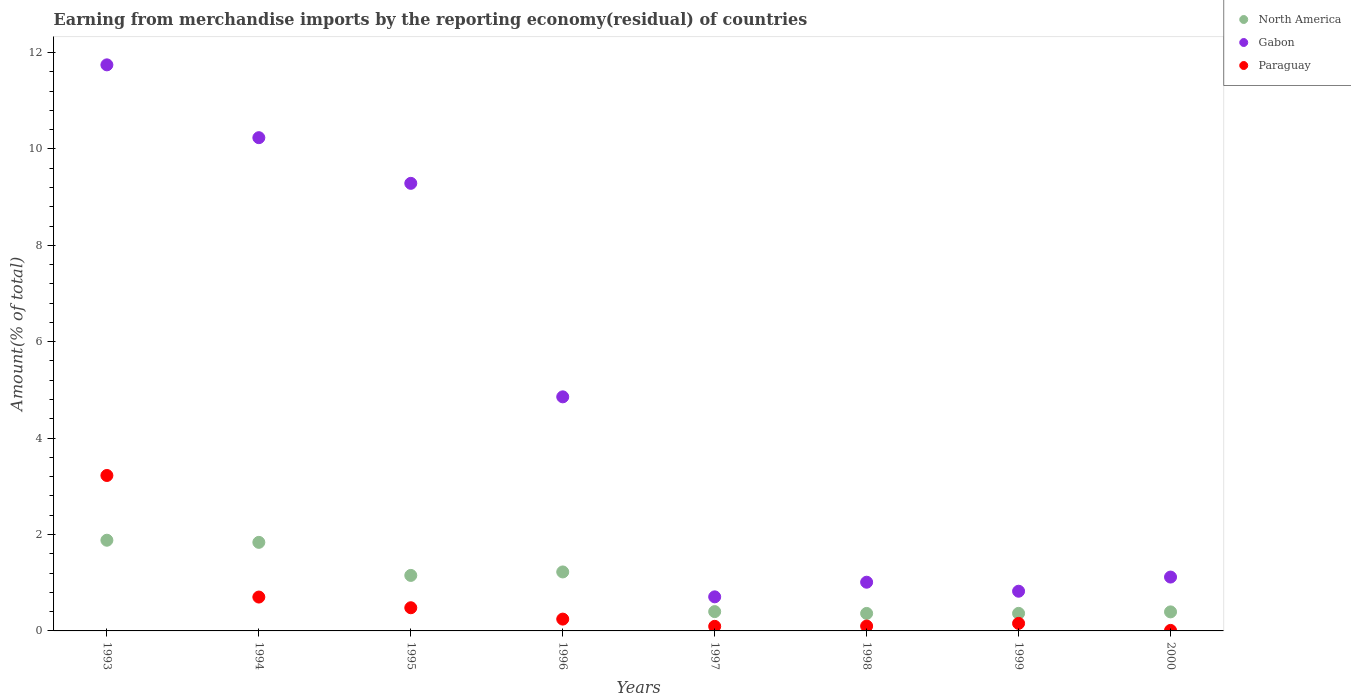Is the number of dotlines equal to the number of legend labels?
Offer a terse response. Yes. What is the percentage of amount earned from merchandise imports in Paraguay in 1994?
Your answer should be very brief. 0.7. Across all years, what is the maximum percentage of amount earned from merchandise imports in Gabon?
Your answer should be compact. 11.74. Across all years, what is the minimum percentage of amount earned from merchandise imports in Gabon?
Provide a short and direct response. 0.71. What is the total percentage of amount earned from merchandise imports in Gabon in the graph?
Give a very brief answer. 39.77. What is the difference between the percentage of amount earned from merchandise imports in North America in 1995 and that in 2000?
Keep it short and to the point. 0.76. What is the difference between the percentage of amount earned from merchandise imports in Gabon in 1993 and the percentage of amount earned from merchandise imports in North America in 1999?
Ensure brevity in your answer.  11.38. What is the average percentage of amount earned from merchandise imports in North America per year?
Give a very brief answer. 0.95. In the year 1995, what is the difference between the percentage of amount earned from merchandise imports in Paraguay and percentage of amount earned from merchandise imports in North America?
Your answer should be very brief. -0.67. In how many years, is the percentage of amount earned from merchandise imports in North America greater than 7.6 %?
Make the answer very short. 0. What is the ratio of the percentage of amount earned from merchandise imports in Paraguay in 1995 to that in 1998?
Your answer should be compact. 4.77. Is the percentage of amount earned from merchandise imports in Paraguay in 1995 less than that in 1997?
Your response must be concise. No. What is the difference between the highest and the second highest percentage of amount earned from merchandise imports in Paraguay?
Offer a terse response. 2.52. What is the difference between the highest and the lowest percentage of amount earned from merchandise imports in North America?
Your response must be concise. 1.52. Is the sum of the percentage of amount earned from merchandise imports in Paraguay in 1995 and 1996 greater than the maximum percentage of amount earned from merchandise imports in Gabon across all years?
Give a very brief answer. No. Is it the case that in every year, the sum of the percentage of amount earned from merchandise imports in North America and percentage of amount earned from merchandise imports in Paraguay  is greater than the percentage of amount earned from merchandise imports in Gabon?
Your response must be concise. No. Is the percentage of amount earned from merchandise imports in Paraguay strictly less than the percentage of amount earned from merchandise imports in Gabon over the years?
Give a very brief answer. Yes. How many years are there in the graph?
Provide a short and direct response. 8. Does the graph contain any zero values?
Your answer should be compact. No. Does the graph contain grids?
Offer a terse response. No. How many legend labels are there?
Offer a very short reply. 3. How are the legend labels stacked?
Make the answer very short. Vertical. What is the title of the graph?
Your answer should be very brief. Earning from merchandise imports by the reporting economy(residual) of countries. What is the label or title of the X-axis?
Keep it short and to the point. Years. What is the label or title of the Y-axis?
Provide a short and direct response. Amount(% of total). What is the Amount(% of total) in North America in 1993?
Give a very brief answer. 1.88. What is the Amount(% of total) of Gabon in 1993?
Your response must be concise. 11.74. What is the Amount(% of total) in Paraguay in 1993?
Your answer should be compact. 3.22. What is the Amount(% of total) of North America in 1994?
Keep it short and to the point. 1.84. What is the Amount(% of total) of Gabon in 1994?
Keep it short and to the point. 10.23. What is the Amount(% of total) in Paraguay in 1994?
Offer a very short reply. 0.7. What is the Amount(% of total) in North America in 1995?
Provide a succinct answer. 1.15. What is the Amount(% of total) in Gabon in 1995?
Your answer should be very brief. 9.29. What is the Amount(% of total) in Paraguay in 1995?
Offer a very short reply. 0.48. What is the Amount(% of total) of North America in 1996?
Make the answer very short. 1.22. What is the Amount(% of total) in Gabon in 1996?
Offer a very short reply. 4.86. What is the Amount(% of total) in Paraguay in 1996?
Offer a terse response. 0.25. What is the Amount(% of total) of North America in 1997?
Provide a short and direct response. 0.4. What is the Amount(% of total) of Gabon in 1997?
Offer a terse response. 0.71. What is the Amount(% of total) in Paraguay in 1997?
Offer a terse response. 0.09. What is the Amount(% of total) of North America in 1998?
Make the answer very short. 0.36. What is the Amount(% of total) in Gabon in 1998?
Keep it short and to the point. 1.01. What is the Amount(% of total) in Paraguay in 1998?
Provide a succinct answer. 0.1. What is the Amount(% of total) of North America in 1999?
Your response must be concise. 0.36. What is the Amount(% of total) of Gabon in 1999?
Make the answer very short. 0.82. What is the Amount(% of total) of Paraguay in 1999?
Your answer should be compact. 0.16. What is the Amount(% of total) of North America in 2000?
Make the answer very short. 0.39. What is the Amount(% of total) of Gabon in 2000?
Keep it short and to the point. 1.12. What is the Amount(% of total) in Paraguay in 2000?
Your answer should be compact. 0.01. Across all years, what is the maximum Amount(% of total) of North America?
Offer a very short reply. 1.88. Across all years, what is the maximum Amount(% of total) of Gabon?
Give a very brief answer. 11.74. Across all years, what is the maximum Amount(% of total) in Paraguay?
Keep it short and to the point. 3.22. Across all years, what is the minimum Amount(% of total) in North America?
Provide a short and direct response. 0.36. Across all years, what is the minimum Amount(% of total) in Gabon?
Offer a terse response. 0.71. Across all years, what is the minimum Amount(% of total) in Paraguay?
Give a very brief answer. 0.01. What is the total Amount(% of total) in North America in the graph?
Make the answer very short. 7.62. What is the total Amount(% of total) of Gabon in the graph?
Give a very brief answer. 39.77. What is the total Amount(% of total) in Paraguay in the graph?
Offer a terse response. 5.02. What is the difference between the Amount(% of total) in North America in 1993 and that in 1994?
Provide a short and direct response. 0.04. What is the difference between the Amount(% of total) of Gabon in 1993 and that in 1994?
Keep it short and to the point. 1.51. What is the difference between the Amount(% of total) of Paraguay in 1993 and that in 1994?
Make the answer very short. 2.52. What is the difference between the Amount(% of total) of North America in 1993 and that in 1995?
Your answer should be very brief. 0.73. What is the difference between the Amount(% of total) of Gabon in 1993 and that in 1995?
Make the answer very short. 2.46. What is the difference between the Amount(% of total) in Paraguay in 1993 and that in 1995?
Give a very brief answer. 2.74. What is the difference between the Amount(% of total) in North America in 1993 and that in 1996?
Give a very brief answer. 0.66. What is the difference between the Amount(% of total) in Gabon in 1993 and that in 1996?
Keep it short and to the point. 6.89. What is the difference between the Amount(% of total) of Paraguay in 1993 and that in 1996?
Your response must be concise. 2.98. What is the difference between the Amount(% of total) of North America in 1993 and that in 1997?
Keep it short and to the point. 1.48. What is the difference between the Amount(% of total) in Gabon in 1993 and that in 1997?
Offer a very short reply. 11.04. What is the difference between the Amount(% of total) of Paraguay in 1993 and that in 1997?
Provide a short and direct response. 3.13. What is the difference between the Amount(% of total) of North America in 1993 and that in 1998?
Provide a succinct answer. 1.52. What is the difference between the Amount(% of total) of Gabon in 1993 and that in 1998?
Ensure brevity in your answer.  10.73. What is the difference between the Amount(% of total) in Paraguay in 1993 and that in 1998?
Give a very brief answer. 3.12. What is the difference between the Amount(% of total) of North America in 1993 and that in 1999?
Make the answer very short. 1.52. What is the difference between the Amount(% of total) in Gabon in 1993 and that in 1999?
Offer a terse response. 10.92. What is the difference between the Amount(% of total) in Paraguay in 1993 and that in 1999?
Provide a short and direct response. 3.07. What is the difference between the Amount(% of total) of North America in 1993 and that in 2000?
Give a very brief answer. 1.49. What is the difference between the Amount(% of total) in Gabon in 1993 and that in 2000?
Your answer should be compact. 10.63. What is the difference between the Amount(% of total) of Paraguay in 1993 and that in 2000?
Your response must be concise. 3.21. What is the difference between the Amount(% of total) of North America in 1994 and that in 1995?
Your answer should be very brief. 0.69. What is the difference between the Amount(% of total) in Gabon in 1994 and that in 1995?
Ensure brevity in your answer.  0.95. What is the difference between the Amount(% of total) in Paraguay in 1994 and that in 1995?
Make the answer very short. 0.22. What is the difference between the Amount(% of total) of North America in 1994 and that in 1996?
Offer a terse response. 0.61. What is the difference between the Amount(% of total) of Gabon in 1994 and that in 1996?
Make the answer very short. 5.38. What is the difference between the Amount(% of total) in Paraguay in 1994 and that in 1996?
Ensure brevity in your answer.  0.46. What is the difference between the Amount(% of total) in North America in 1994 and that in 1997?
Ensure brevity in your answer.  1.44. What is the difference between the Amount(% of total) of Gabon in 1994 and that in 1997?
Ensure brevity in your answer.  9.53. What is the difference between the Amount(% of total) of Paraguay in 1994 and that in 1997?
Provide a succinct answer. 0.61. What is the difference between the Amount(% of total) in North America in 1994 and that in 1998?
Ensure brevity in your answer.  1.47. What is the difference between the Amount(% of total) in Gabon in 1994 and that in 1998?
Provide a succinct answer. 9.22. What is the difference between the Amount(% of total) of Paraguay in 1994 and that in 1998?
Provide a short and direct response. 0.6. What is the difference between the Amount(% of total) in North America in 1994 and that in 1999?
Give a very brief answer. 1.47. What is the difference between the Amount(% of total) in Gabon in 1994 and that in 1999?
Keep it short and to the point. 9.41. What is the difference between the Amount(% of total) in Paraguay in 1994 and that in 1999?
Provide a short and direct response. 0.55. What is the difference between the Amount(% of total) in North America in 1994 and that in 2000?
Offer a terse response. 1.44. What is the difference between the Amount(% of total) in Gabon in 1994 and that in 2000?
Make the answer very short. 9.12. What is the difference between the Amount(% of total) in Paraguay in 1994 and that in 2000?
Provide a short and direct response. 0.69. What is the difference between the Amount(% of total) of North America in 1995 and that in 1996?
Your answer should be very brief. -0.07. What is the difference between the Amount(% of total) of Gabon in 1995 and that in 1996?
Give a very brief answer. 4.43. What is the difference between the Amount(% of total) of Paraguay in 1995 and that in 1996?
Give a very brief answer. 0.24. What is the difference between the Amount(% of total) of North America in 1995 and that in 1997?
Keep it short and to the point. 0.75. What is the difference between the Amount(% of total) of Gabon in 1995 and that in 1997?
Make the answer very short. 8.58. What is the difference between the Amount(% of total) of Paraguay in 1995 and that in 1997?
Your response must be concise. 0.39. What is the difference between the Amount(% of total) in North America in 1995 and that in 1998?
Keep it short and to the point. 0.79. What is the difference between the Amount(% of total) in Gabon in 1995 and that in 1998?
Your response must be concise. 8.27. What is the difference between the Amount(% of total) of Paraguay in 1995 and that in 1998?
Keep it short and to the point. 0.38. What is the difference between the Amount(% of total) in North America in 1995 and that in 1999?
Offer a very short reply. 0.79. What is the difference between the Amount(% of total) of Gabon in 1995 and that in 1999?
Give a very brief answer. 8.46. What is the difference between the Amount(% of total) of Paraguay in 1995 and that in 1999?
Your answer should be very brief. 0.32. What is the difference between the Amount(% of total) in North America in 1995 and that in 2000?
Your answer should be compact. 0.76. What is the difference between the Amount(% of total) in Gabon in 1995 and that in 2000?
Make the answer very short. 8.17. What is the difference between the Amount(% of total) of Paraguay in 1995 and that in 2000?
Offer a terse response. 0.47. What is the difference between the Amount(% of total) of North America in 1996 and that in 1997?
Ensure brevity in your answer.  0.82. What is the difference between the Amount(% of total) of Gabon in 1996 and that in 1997?
Offer a very short reply. 4.15. What is the difference between the Amount(% of total) of Paraguay in 1996 and that in 1997?
Ensure brevity in your answer.  0.15. What is the difference between the Amount(% of total) of North America in 1996 and that in 1998?
Make the answer very short. 0.86. What is the difference between the Amount(% of total) in Gabon in 1996 and that in 1998?
Keep it short and to the point. 3.85. What is the difference between the Amount(% of total) in Paraguay in 1996 and that in 1998?
Keep it short and to the point. 0.14. What is the difference between the Amount(% of total) in North America in 1996 and that in 1999?
Make the answer very short. 0.86. What is the difference between the Amount(% of total) of Gabon in 1996 and that in 1999?
Your answer should be very brief. 4.03. What is the difference between the Amount(% of total) in Paraguay in 1996 and that in 1999?
Offer a terse response. 0.09. What is the difference between the Amount(% of total) in North America in 1996 and that in 2000?
Ensure brevity in your answer.  0.83. What is the difference between the Amount(% of total) of Gabon in 1996 and that in 2000?
Provide a short and direct response. 3.74. What is the difference between the Amount(% of total) in Paraguay in 1996 and that in 2000?
Offer a very short reply. 0.23. What is the difference between the Amount(% of total) in North America in 1997 and that in 1998?
Give a very brief answer. 0.04. What is the difference between the Amount(% of total) in Gabon in 1997 and that in 1998?
Provide a succinct answer. -0.3. What is the difference between the Amount(% of total) in Paraguay in 1997 and that in 1998?
Offer a terse response. -0.01. What is the difference between the Amount(% of total) of North America in 1997 and that in 1999?
Your response must be concise. 0.04. What is the difference between the Amount(% of total) in Gabon in 1997 and that in 1999?
Keep it short and to the point. -0.12. What is the difference between the Amount(% of total) of Paraguay in 1997 and that in 1999?
Your answer should be very brief. -0.06. What is the difference between the Amount(% of total) in North America in 1997 and that in 2000?
Your response must be concise. 0.01. What is the difference between the Amount(% of total) of Gabon in 1997 and that in 2000?
Make the answer very short. -0.41. What is the difference between the Amount(% of total) of Paraguay in 1997 and that in 2000?
Give a very brief answer. 0.08. What is the difference between the Amount(% of total) of North America in 1998 and that in 1999?
Ensure brevity in your answer.  -0. What is the difference between the Amount(% of total) in Gabon in 1998 and that in 1999?
Make the answer very short. 0.19. What is the difference between the Amount(% of total) in Paraguay in 1998 and that in 1999?
Offer a very short reply. -0.06. What is the difference between the Amount(% of total) of North America in 1998 and that in 2000?
Provide a succinct answer. -0.03. What is the difference between the Amount(% of total) of Gabon in 1998 and that in 2000?
Give a very brief answer. -0.11. What is the difference between the Amount(% of total) of Paraguay in 1998 and that in 2000?
Your answer should be compact. 0.09. What is the difference between the Amount(% of total) of North America in 1999 and that in 2000?
Provide a succinct answer. -0.03. What is the difference between the Amount(% of total) of Gabon in 1999 and that in 2000?
Make the answer very short. -0.29. What is the difference between the Amount(% of total) in Paraguay in 1999 and that in 2000?
Your answer should be very brief. 0.15. What is the difference between the Amount(% of total) of North America in 1993 and the Amount(% of total) of Gabon in 1994?
Keep it short and to the point. -8.35. What is the difference between the Amount(% of total) in North America in 1993 and the Amount(% of total) in Paraguay in 1994?
Your answer should be compact. 1.18. What is the difference between the Amount(% of total) of Gabon in 1993 and the Amount(% of total) of Paraguay in 1994?
Provide a short and direct response. 11.04. What is the difference between the Amount(% of total) in North America in 1993 and the Amount(% of total) in Gabon in 1995?
Keep it short and to the point. -7.4. What is the difference between the Amount(% of total) in North America in 1993 and the Amount(% of total) in Paraguay in 1995?
Ensure brevity in your answer.  1.4. What is the difference between the Amount(% of total) of Gabon in 1993 and the Amount(% of total) of Paraguay in 1995?
Keep it short and to the point. 11.26. What is the difference between the Amount(% of total) in North America in 1993 and the Amount(% of total) in Gabon in 1996?
Offer a very short reply. -2.97. What is the difference between the Amount(% of total) in North America in 1993 and the Amount(% of total) in Paraguay in 1996?
Keep it short and to the point. 1.64. What is the difference between the Amount(% of total) in Gabon in 1993 and the Amount(% of total) in Paraguay in 1996?
Your answer should be very brief. 11.5. What is the difference between the Amount(% of total) in North America in 1993 and the Amount(% of total) in Gabon in 1997?
Provide a short and direct response. 1.17. What is the difference between the Amount(% of total) of North America in 1993 and the Amount(% of total) of Paraguay in 1997?
Your answer should be very brief. 1.79. What is the difference between the Amount(% of total) in Gabon in 1993 and the Amount(% of total) in Paraguay in 1997?
Make the answer very short. 11.65. What is the difference between the Amount(% of total) of North America in 1993 and the Amount(% of total) of Gabon in 1998?
Keep it short and to the point. 0.87. What is the difference between the Amount(% of total) in North America in 1993 and the Amount(% of total) in Paraguay in 1998?
Offer a terse response. 1.78. What is the difference between the Amount(% of total) of Gabon in 1993 and the Amount(% of total) of Paraguay in 1998?
Offer a terse response. 11.64. What is the difference between the Amount(% of total) of North America in 1993 and the Amount(% of total) of Gabon in 1999?
Provide a succinct answer. 1.06. What is the difference between the Amount(% of total) of North America in 1993 and the Amount(% of total) of Paraguay in 1999?
Keep it short and to the point. 1.72. What is the difference between the Amount(% of total) of Gabon in 1993 and the Amount(% of total) of Paraguay in 1999?
Offer a very short reply. 11.59. What is the difference between the Amount(% of total) of North America in 1993 and the Amount(% of total) of Gabon in 2000?
Your answer should be very brief. 0.76. What is the difference between the Amount(% of total) of North America in 1993 and the Amount(% of total) of Paraguay in 2000?
Your answer should be compact. 1.87. What is the difference between the Amount(% of total) in Gabon in 1993 and the Amount(% of total) in Paraguay in 2000?
Your answer should be compact. 11.73. What is the difference between the Amount(% of total) in North America in 1994 and the Amount(% of total) in Gabon in 1995?
Offer a terse response. -7.45. What is the difference between the Amount(% of total) in North America in 1994 and the Amount(% of total) in Paraguay in 1995?
Ensure brevity in your answer.  1.36. What is the difference between the Amount(% of total) of Gabon in 1994 and the Amount(% of total) of Paraguay in 1995?
Keep it short and to the point. 9.75. What is the difference between the Amount(% of total) of North America in 1994 and the Amount(% of total) of Gabon in 1996?
Your answer should be compact. -3.02. What is the difference between the Amount(% of total) in North America in 1994 and the Amount(% of total) in Paraguay in 1996?
Keep it short and to the point. 1.59. What is the difference between the Amount(% of total) of Gabon in 1994 and the Amount(% of total) of Paraguay in 1996?
Make the answer very short. 9.99. What is the difference between the Amount(% of total) of North America in 1994 and the Amount(% of total) of Gabon in 1997?
Ensure brevity in your answer.  1.13. What is the difference between the Amount(% of total) in North America in 1994 and the Amount(% of total) in Paraguay in 1997?
Offer a very short reply. 1.74. What is the difference between the Amount(% of total) in Gabon in 1994 and the Amount(% of total) in Paraguay in 1997?
Offer a terse response. 10.14. What is the difference between the Amount(% of total) in North America in 1994 and the Amount(% of total) in Gabon in 1998?
Ensure brevity in your answer.  0.83. What is the difference between the Amount(% of total) in North America in 1994 and the Amount(% of total) in Paraguay in 1998?
Give a very brief answer. 1.74. What is the difference between the Amount(% of total) of Gabon in 1994 and the Amount(% of total) of Paraguay in 1998?
Keep it short and to the point. 10.13. What is the difference between the Amount(% of total) in North America in 1994 and the Amount(% of total) in Gabon in 1999?
Your response must be concise. 1.01. What is the difference between the Amount(% of total) of North America in 1994 and the Amount(% of total) of Paraguay in 1999?
Provide a succinct answer. 1.68. What is the difference between the Amount(% of total) of Gabon in 1994 and the Amount(% of total) of Paraguay in 1999?
Give a very brief answer. 10.08. What is the difference between the Amount(% of total) in North America in 1994 and the Amount(% of total) in Gabon in 2000?
Make the answer very short. 0.72. What is the difference between the Amount(% of total) of North America in 1994 and the Amount(% of total) of Paraguay in 2000?
Your response must be concise. 1.83. What is the difference between the Amount(% of total) in Gabon in 1994 and the Amount(% of total) in Paraguay in 2000?
Provide a succinct answer. 10.22. What is the difference between the Amount(% of total) of North America in 1995 and the Amount(% of total) of Gabon in 1996?
Offer a very short reply. -3.7. What is the difference between the Amount(% of total) in North America in 1995 and the Amount(% of total) in Paraguay in 1996?
Provide a succinct answer. 0.91. What is the difference between the Amount(% of total) in Gabon in 1995 and the Amount(% of total) in Paraguay in 1996?
Offer a terse response. 9.04. What is the difference between the Amount(% of total) of North America in 1995 and the Amount(% of total) of Gabon in 1997?
Offer a very short reply. 0.44. What is the difference between the Amount(% of total) in North America in 1995 and the Amount(% of total) in Paraguay in 1997?
Your response must be concise. 1.06. What is the difference between the Amount(% of total) of Gabon in 1995 and the Amount(% of total) of Paraguay in 1997?
Offer a terse response. 9.19. What is the difference between the Amount(% of total) of North America in 1995 and the Amount(% of total) of Gabon in 1998?
Provide a short and direct response. 0.14. What is the difference between the Amount(% of total) in North America in 1995 and the Amount(% of total) in Paraguay in 1998?
Give a very brief answer. 1.05. What is the difference between the Amount(% of total) of Gabon in 1995 and the Amount(% of total) of Paraguay in 1998?
Your answer should be very brief. 9.18. What is the difference between the Amount(% of total) in North America in 1995 and the Amount(% of total) in Gabon in 1999?
Keep it short and to the point. 0.33. What is the difference between the Amount(% of total) of Gabon in 1995 and the Amount(% of total) of Paraguay in 1999?
Your answer should be very brief. 9.13. What is the difference between the Amount(% of total) in North America in 1995 and the Amount(% of total) in Gabon in 2000?
Give a very brief answer. 0.03. What is the difference between the Amount(% of total) in North America in 1995 and the Amount(% of total) in Paraguay in 2000?
Give a very brief answer. 1.14. What is the difference between the Amount(% of total) in Gabon in 1995 and the Amount(% of total) in Paraguay in 2000?
Give a very brief answer. 9.27. What is the difference between the Amount(% of total) of North America in 1996 and the Amount(% of total) of Gabon in 1997?
Give a very brief answer. 0.52. What is the difference between the Amount(% of total) in North America in 1996 and the Amount(% of total) in Paraguay in 1997?
Offer a very short reply. 1.13. What is the difference between the Amount(% of total) in Gabon in 1996 and the Amount(% of total) in Paraguay in 1997?
Ensure brevity in your answer.  4.76. What is the difference between the Amount(% of total) of North America in 1996 and the Amount(% of total) of Gabon in 1998?
Offer a very short reply. 0.21. What is the difference between the Amount(% of total) of North America in 1996 and the Amount(% of total) of Paraguay in 1998?
Give a very brief answer. 1.12. What is the difference between the Amount(% of total) in Gabon in 1996 and the Amount(% of total) in Paraguay in 1998?
Your answer should be very brief. 4.76. What is the difference between the Amount(% of total) in North America in 1996 and the Amount(% of total) in Gabon in 1999?
Your response must be concise. 0.4. What is the difference between the Amount(% of total) of North America in 1996 and the Amount(% of total) of Paraguay in 1999?
Offer a terse response. 1.07. What is the difference between the Amount(% of total) of Gabon in 1996 and the Amount(% of total) of Paraguay in 1999?
Keep it short and to the point. 4.7. What is the difference between the Amount(% of total) of North America in 1996 and the Amount(% of total) of Gabon in 2000?
Keep it short and to the point. 0.11. What is the difference between the Amount(% of total) in North America in 1996 and the Amount(% of total) in Paraguay in 2000?
Ensure brevity in your answer.  1.21. What is the difference between the Amount(% of total) of Gabon in 1996 and the Amount(% of total) of Paraguay in 2000?
Keep it short and to the point. 4.85. What is the difference between the Amount(% of total) of North America in 1997 and the Amount(% of total) of Gabon in 1998?
Ensure brevity in your answer.  -0.61. What is the difference between the Amount(% of total) in Gabon in 1997 and the Amount(% of total) in Paraguay in 1998?
Provide a succinct answer. 0.61. What is the difference between the Amount(% of total) of North America in 1997 and the Amount(% of total) of Gabon in 1999?
Your answer should be compact. -0.42. What is the difference between the Amount(% of total) in North America in 1997 and the Amount(% of total) in Paraguay in 1999?
Your response must be concise. 0.24. What is the difference between the Amount(% of total) of Gabon in 1997 and the Amount(% of total) of Paraguay in 1999?
Your answer should be very brief. 0.55. What is the difference between the Amount(% of total) in North America in 1997 and the Amount(% of total) in Gabon in 2000?
Offer a very short reply. -0.72. What is the difference between the Amount(% of total) of North America in 1997 and the Amount(% of total) of Paraguay in 2000?
Provide a succinct answer. 0.39. What is the difference between the Amount(% of total) in Gabon in 1997 and the Amount(% of total) in Paraguay in 2000?
Give a very brief answer. 0.7. What is the difference between the Amount(% of total) in North America in 1998 and the Amount(% of total) in Gabon in 1999?
Your answer should be compact. -0.46. What is the difference between the Amount(% of total) in North America in 1998 and the Amount(% of total) in Paraguay in 1999?
Keep it short and to the point. 0.21. What is the difference between the Amount(% of total) in Gabon in 1998 and the Amount(% of total) in Paraguay in 1999?
Your response must be concise. 0.85. What is the difference between the Amount(% of total) in North America in 1998 and the Amount(% of total) in Gabon in 2000?
Keep it short and to the point. -0.75. What is the difference between the Amount(% of total) of North America in 1998 and the Amount(% of total) of Paraguay in 2000?
Offer a terse response. 0.35. What is the difference between the Amount(% of total) of Gabon in 1998 and the Amount(% of total) of Paraguay in 2000?
Ensure brevity in your answer.  1. What is the difference between the Amount(% of total) of North America in 1999 and the Amount(% of total) of Gabon in 2000?
Ensure brevity in your answer.  -0.75. What is the difference between the Amount(% of total) in North America in 1999 and the Amount(% of total) in Paraguay in 2000?
Keep it short and to the point. 0.35. What is the difference between the Amount(% of total) of Gabon in 1999 and the Amount(% of total) of Paraguay in 2000?
Your answer should be compact. 0.81. What is the average Amount(% of total) in North America per year?
Keep it short and to the point. 0.95. What is the average Amount(% of total) of Gabon per year?
Make the answer very short. 4.97. What is the average Amount(% of total) in Paraguay per year?
Keep it short and to the point. 0.63. In the year 1993, what is the difference between the Amount(% of total) in North America and Amount(% of total) in Gabon?
Provide a short and direct response. -9.86. In the year 1993, what is the difference between the Amount(% of total) of North America and Amount(% of total) of Paraguay?
Your response must be concise. -1.34. In the year 1993, what is the difference between the Amount(% of total) of Gabon and Amount(% of total) of Paraguay?
Offer a terse response. 8.52. In the year 1994, what is the difference between the Amount(% of total) of North America and Amount(% of total) of Gabon?
Your answer should be very brief. -8.4. In the year 1994, what is the difference between the Amount(% of total) in North America and Amount(% of total) in Paraguay?
Make the answer very short. 1.13. In the year 1994, what is the difference between the Amount(% of total) in Gabon and Amount(% of total) in Paraguay?
Give a very brief answer. 9.53. In the year 1995, what is the difference between the Amount(% of total) of North America and Amount(% of total) of Gabon?
Your answer should be very brief. -8.13. In the year 1995, what is the difference between the Amount(% of total) in North America and Amount(% of total) in Paraguay?
Ensure brevity in your answer.  0.67. In the year 1995, what is the difference between the Amount(% of total) in Gabon and Amount(% of total) in Paraguay?
Give a very brief answer. 8.8. In the year 1996, what is the difference between the Amount(% of total) in North America and Amount(% of total) in Gabon?
Provide a short and direct response. -3.63. In the year 1996, what is the difference between the Amount(% of total) of North America and Amount(% of total) of Paraguay?
Provide a short and direct response. 0.98. In the year 1996, what is the difference between the Amount(% of total) in Gabon and Amount(% of total) in Paraguay?
Offer a very short reply. 4.61. In the year 1997, what is the difference between the Amount(% of total) of North America and Amount(% of total) of Gabon?
Provide a succinct answer. -0.31. In the year 1997, what is the difference between the Amount(% of total) of North America and Amount(% of total) of Paraguay?
Give a very brief answer. 0.31. In the year 1997, what is the difference between the Amount(% of total) in Gabon and Amount(% of total) in Paraguay?
Make the answer very short. 0.61. In the year 1998, what is the difference between the Amount(% of total) of North America and Amount(% of total) of Gabon?
Provide a succinct answer. -0.65. In the year 1998, what is the difference between the Amount(% of total) in North America and Amount(% of total) in Paraguay?
Your answer should be compact. 0.26. In the year 1998, what is the difference between the Amount(% of total) of Gabon and Amount(% of total) of Paraguay?
Your answer should be very brief. 0.91. In the year 1999, what is the difference between the Amount(% of total) in North America and Amount(% of total) in Gabon?
Provide a short and direct response. -0.46. In the year 1999, what is the difference between the Amount(% of total) in North America and Amount(% of total) in Paraguay?
Offer a terse response. 0.21. In the year 1999, what is the difference between the Amount(% of total) of Gabon and Amount(% of total) of Paraguay?
Provide a short and direct response. 0.67. In the year 2000, what is the difference between the Amount(% of total) in North America and Amount(% of total) in Gabon?
Provide a short and direct response. -0.72. In the year 2000, what is the difference between the Amount(% of total) of North America and Amount(% of total) of Paraguay?
Your response must be concise. 0.38. In the year 2000, what is the difference between the Amount(% of total) of Gabon and Amount(% of total) of Paraguay?
Your answer should be very brief. 1.11. What is the ratio of the Amount(% of total) in North America in 1993 to that in 1994?
Make the answer very short. 1.02. What is the ratio of the Amount(% of total) in Gabon in 1993 to that in 1994?
Provide a short and direct response. 1.15. What is the ratio of the Amount(% of total) in Paraguay in 1993 to that in 1994?
Your answer should be very brief. 4.59. What is the ratio of the Amount(% of total) in North America in 1993 to that in 1995?
Your response must be concise. 1.63. What is the ratio of the Amount(% of total) of Gabon in 1993 to that in 1995?
Your answer should be very brief. 1.26. What is the ratio of the Amount(% of total) of Paraguay in 1993 to that in 1995?
Your answer should be very brief. 6.71. What is the ratio of the Amount(% of total) in North America in 1993 to that in 1996?
Your response must be concise. 1.54. What is the ratio of the Amount(% of total) of Gabon in 1993 to that in 1996?
Your answer should be very brief. 2.42. What is the ratio of the Amount(% of total) of Paraguay in 1993 to that in 1996?
Your answer should be very brief. 13.16. What is the ratio of the Amount(% of total) of North America in 1993 to that in 1997?
Your response must be concise. 4.7. What is the ratio of the Amount(% of total) of Gabon in 1993 to that in 1997?
Make the answer very short. 16.61. What is the ratio of the Amount(% of total) of Paraguay in 1993 to that in 1997?
Provide a succinct answer. 33.98. What is the ratio of the Amount(% of total) in North America in 1993 to that in 1998?
Ensure brevity in your answer.  5.18. What is the ratio of the Amount(% of total) in Gabon in 1993 to that in 1998?
Ensure brevity in your answer.  11.62. What is the ratio of the Amount(% of total) of Paraguay in 1993 to that in 1998?
Give a very brief answer. 32.02. What is the ratio of the Amount(% of total) in North America in 1993 to that in 1999?
Provide a succinct answer. 5.17. What is the ratio of the Amount(% of total) in Gabon in 1993 to that in 1999?
Offer a very short reply. 14.26. What is the ratio of the Amount(% of total) of Paraguay in 1993 to that in 1999?
Make the answer very short. 20.6. What is the ratio of the Amount(% of total) in North America in 1993 to that in 2000?
Provide a succinct answer. 4.76. What is the ratio of the Amount(% of total) of Gabon in 1993 to that in 2000?
Give a very brief answer. 10.51. What is the ratio of the Amount(% of total) in Paraguay in 1993 to that in 2000?
Your answer should be very brief. 297.2. What is the ratio of the Amount(% of total) of North America in 1994 to that in 1995?
Provide a succinct answer. 1.6. What is the ratio of the Amount(% of total) of Gabon in 1994 to that in 1995?
Provide a succinct answer. 1.1. What is the ratio of the Amount(% of total) of Paraguay in 1994 to that in 1995?
Your answer should be very brief. 1.46. What is the ratio of the Amount(% of total) in North America in 1994 to that in 1996?
Your answer should be very brief. 1.5. What is the ratio of the Amount(% of total) in Gabon in 1994 to that in 1996?
Your answer should be compact. 2.11. What is the ratio of the Amount(% of total) in Paraguay in 1994 to that in 1996?
Offer a terse response. 2.87. What is the ratio of the Amount(% of total) of North America in 1994 to that in 1997?
Give a very brief answer. 4.59. What is the ratio of the Amount(% of total) of Gabon in 1994 to that in 1997?
Offer a terse response. 14.47. What is the ratio of the Amount(% of total) of Paraguay in 1994 to that in 1997?
Offer a very short reply. 7.4. What is the ratio of the Amount(% of total) in North America in 1994 to that in 1998?
Provide a succinct answer. 5.06. What is the ratio of the Amount(% of total) of Gabon in 1994 to that in 1998?
Ensure brevity in your answer.  10.13. What is the ratio of the Amount(% of total) of Paraguay in 1994 to that in 1998?
Ensure brevity in your answer.  6.98. What is the ratio of the Amount(% of total) of North America in 1994 to that in 1999?
Provide a short and direct response. 5.05. What is the ratio of the Amount(% of total) in Gabon in 1994 to that in 1999?
Offer a very short reply. 12.43. What is the ratio of the Amount(% of total) in Paraguay in 1994 to that in 1999?
Keep it short and to the point. 4.49. What is the ratio of the Amount(% of total) in North America in 1994 to that in 2000?
Ensure brevity in your answer.  4.65. What is the ratio of the Amount(% of total) in Gabon in 1994 to that in 2000?
Your answer should be very brief. 9.16. What is the ratio of the Amount(% of total) of Paraguay in 1994 to that in 2000?
Provide a short and direct response. 64.75. What is the ratio of the Amount(% of total) of North America in 1995 to that in 1996?
Offer a very short reply. 0.94. What is the ratio of the Amount(% of total) of Gabon in 1995 to that in 1996?
Give a very brief answer. 1.91. What is the ratio of the Amount(% of total) in Paraguay in 1995 to that in 1996?
Make the answer very short. 1.96. What is the ratio of the Amount(% of total) in North America in 1995 to that in 1997?
Provide a succinct answer. 2.87. What is the ratio of the Amount(% of total) of Gabon in 1995 to that in 1997?
Your answer should be compact. 13.13. What is the ratio of the Amount(% of total) of Paraguay in 1995 to that in 1997?
Offer a terse response. 5.07. What is the ratio of the Amount(% of total) in North America in 1995 to that in 1998?
Offer a very short reply. 3.17. What is the ratio of the Amount(% of total) of Gabon in 1995 to that in 1998?
Your response must be concise. 9.19. What is the ratio of the Amount(% of total) in Paraguay in 1995 to that in 1998?
Make the answer very short. 4.77. What is the ratio of the Amount(% of total) in North America in 1995 to that in 1999?
Keep it short and to the point. 3.16. What is the ratio of the Amount(% of total) in Gabon in 1995 to that in 1999?
Provide a succinct answer. 11.28. What is the ratio of the Amount(% of total) in Paraguay in 1995 to that in 1999?
Offer a very short reply. 3.07. What is the ratio of the Amount(% of total) in North America in 1995 to that in 2000?
Give a very brief answer. 2.92. What is the ratio of the Amount(% of total) of Gabon in 1995 to that in 2000?
Offer a very short reply. 8.31. What is the ratio of the Amount(% of total) of Paraguay in 1995 to that in 2000?
Offer a very short reply. 44.31. What is the ratio of the Amount(% of total) of North America in 1996 to that in 1997?
Offer a terse response. 3.05. What is the ratio of the Amount(% of total) in Gabon in 1996 to that in 1997?
Offer a terse response. 6.87. What is the ratio of the Amount(% of total) in Paraguay in 1996 to that in 1997?
Give a very brief answer. 2.58. What is the ratio of the Amount(% of total) of North America in 1996 to that in 1998?
Provide a short and direct response. 3.37. What is the ratio of the Amount(% of total) of Gabon in 1996 to that in 1998?
Keep it short and to the point. 4.81. What is the ratio of the Amount(% of total) in Paraguay in 1996 to that in 1998?
Keep it short and to the point. 2.43. What is the ratio of the Amount(% of total) in North America in 1996 to that in 1999?
Offer a terse response. 3.36. What is the ratio of the Amount(% of total) in Gabon in 1996 to that in 1999?
Your response must be concise. 5.9. What is the ratio of the Amount(% of total) in Paraguay in 1996 to that in 1999?
Your answer should be compact. 1.57. What is the ratio of the Amount(% of total) of North America in 1996 to that in 2000?
Make the answer very short. 3.1. What is the ratio of the Amount(% of total) of Gabon in 1996 to that in 2000?
Your answer should be very brief. 4.35. What is the ratio of the Amount(% of total) of Paraguay in 1996 to that in 2000?
Give a very brief answer. 22.58. What is the ratio of the Amount(% of total) of North America in 1997 to that in 1998?
Your answer should be compact. 1.1. What is the ratio of the Amount(% of total) of Gabon in 1997 to that in 1998?
Your answer should be compact. 0.7. What is the ratio of the Amount(% of total) of Paraguay in 1997 to that in 1998?
Give a very brief answer. 0.94. What is the ratio of the Amount(% of total) in North America in 1997 to that in 1999?
Offer a very short reply. 1.1. What is the ratio of the Amount(% of total) of Gabon in 1997 to that in 1999?
Make the answer very short. 0.86. What is the ratio of the Amount(% of total) of Paraguay in 1997 to that in 1999?
Your response must be concise. 0.61. What is the ratio of the Amount(% of total) of North America in 1997 to that in 2000?
Make the answer very short. 1.01. What is the ratio of the Amount(% of total) of Gabon in 1997 to that in 2000?
Provide a short and direct response. 0.63. What is the ratio of the Amount(% of total) of Paraguay in 1997 to that in 2000?
Ensure brevity in your answer.  8.75. What is the ratio of the Amount(% of total) of North America in 1998 to that in 1999?
Make the answer very short. 1. What is the ratio of the Amount(% of total) of Gabon in 1998 to that in 1999?
Give a very brief answer. 1.23. What is the ratio of the Amount(% of total) in Paraguay in 1998 to that in 1999?
Your answer should be very brief. 0.64. What is the ratio of the Amount(% of total) of North America in 1998 to that in 2000?
Your answer should be compact. 0.92. What is the ratio of the Amount(% of total) of Gabon in 1998 to that in 2000?
Provide a succinct answer. 0.9. What is the ratio of the Amount(% of total) in Paraguay in 1998 to that in 2000?
Ensure brevity in your answer.  9.28. What is the ratio of the Amount(% of total) in North America in 1999 to that in 2000?
Your answer should be compact. 0.92. What is the ratio of the Amount(% of total) of Gabon in 1999 to that in 2000?
Your response must be concise. 0.74. What is the ratio of the Amount(% of total) in Paraguay in 1999 to that in 2000?
Your response must be concise. 14.43. What is the difference between the highest and the second highest Amount(% of total) in North America?
Your answer should be compact. 0.04. What is the difference between the highest and the second highest Amount(% of total) of Gabon?
Your answer should be compact. 1.51. What is the difference between the highest and the second highest Amount(% of total) of Paraguay?
Keep it short and to the point. 2.52. What is the difference between the highest and the lowest Amount(% of total) in North America?
Provide a succinct answer. 1.52. What is the difference between the highest and the lowest Amount(% of total) of Gabon?
Make the answer very short. 11.04. What is the difference between the highest and the lowest Amount(% of total) in Paraguay?
Keep it short and to the point. 3.21. 